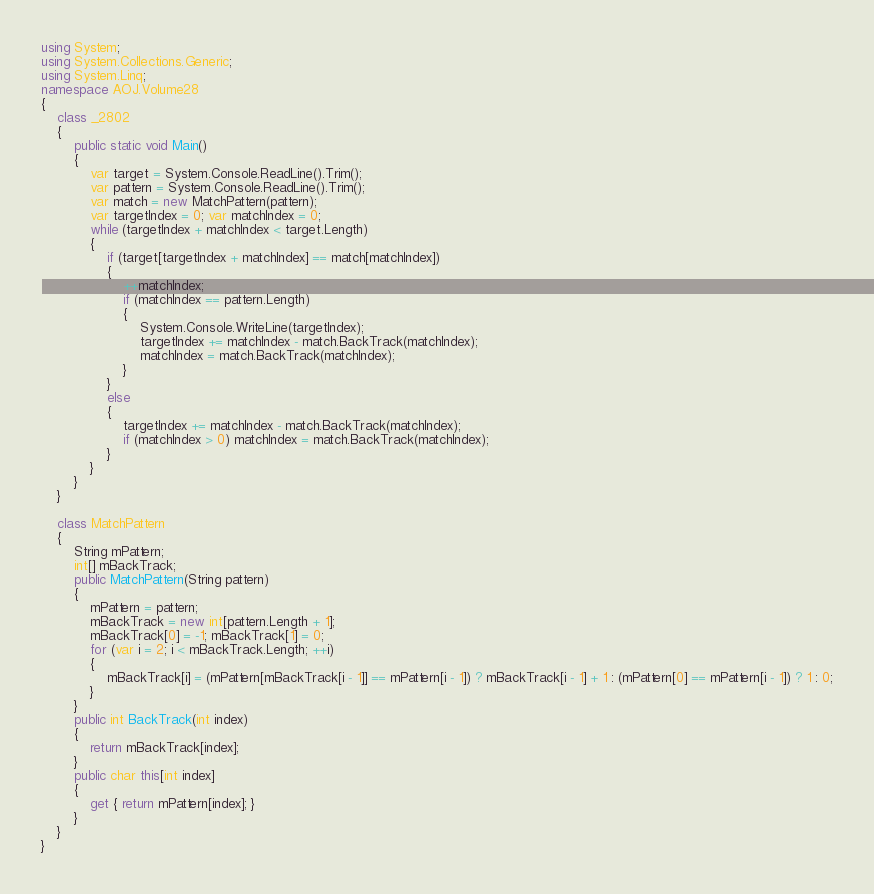Convert code to text. <code><loc_0><loc_0><loc_500><loc_500><_C#_>using System;
using System.Collections.Generic;
using System.Linq;
namespace AOJ.Volume28
{
    class _2802
    {
        public static void Main()
        {
            var target = System.Console.ReadLine().Trim();
            var pattern = System.Console.ReadLine().Trim();
            var match = new MatchPattern(pattern);
            var targetIndex = 0; var matchIndex = 0;
            while (targetIndex + matchIndex < target.Length)
            {
                if (target[targetIndex + matchIndex] == match[matchIndex])
                {
                    ++matchIndex;
                    if (matchIndex == pattern.Length)
                    {
                        System.Console.WriteLine(targetIndex);
                        targetIndex += matchIndex - match.BackTrack(matchIndex);
                        matchIndex = match.BackTrack(matchIndex);
                    }
                }
                else
                {
                    targetIndex += matchIndex - match.BackTrack(matchIndex);
                    if (matchIndex > 0) matchIndex = match.BackTrack(matchIndex);
                }
            }
        }
    }

    class MatchPattern
    {
        String mPattern;
        int[] mBackTrack;
        public MatchPattern(String pattern)
        {
            mPattern = pattern;
            mBackTrack = new int[pattern.Length + 1];
            mBackTrack[0] = -1; mBackTrack[1] = 0;
            for (var i = 2; i < mBackTrack.Length; ++i)
            {
                mBackTrack[i] = (mPattern[mBackTrack[i - 1]] == mPattern[i - 1]) ? mBackTrack[i - 1] + 1 : (mPattern[0] == mPattern[i - 1]) ? 1 : 0;
            }
        }
        public int BackTrack(int index)
        {
            return mBackTrack[index];
        }
        public char this[int index]
        {
            get { return mPattern[index]; }
        }
    }
}

</code> 